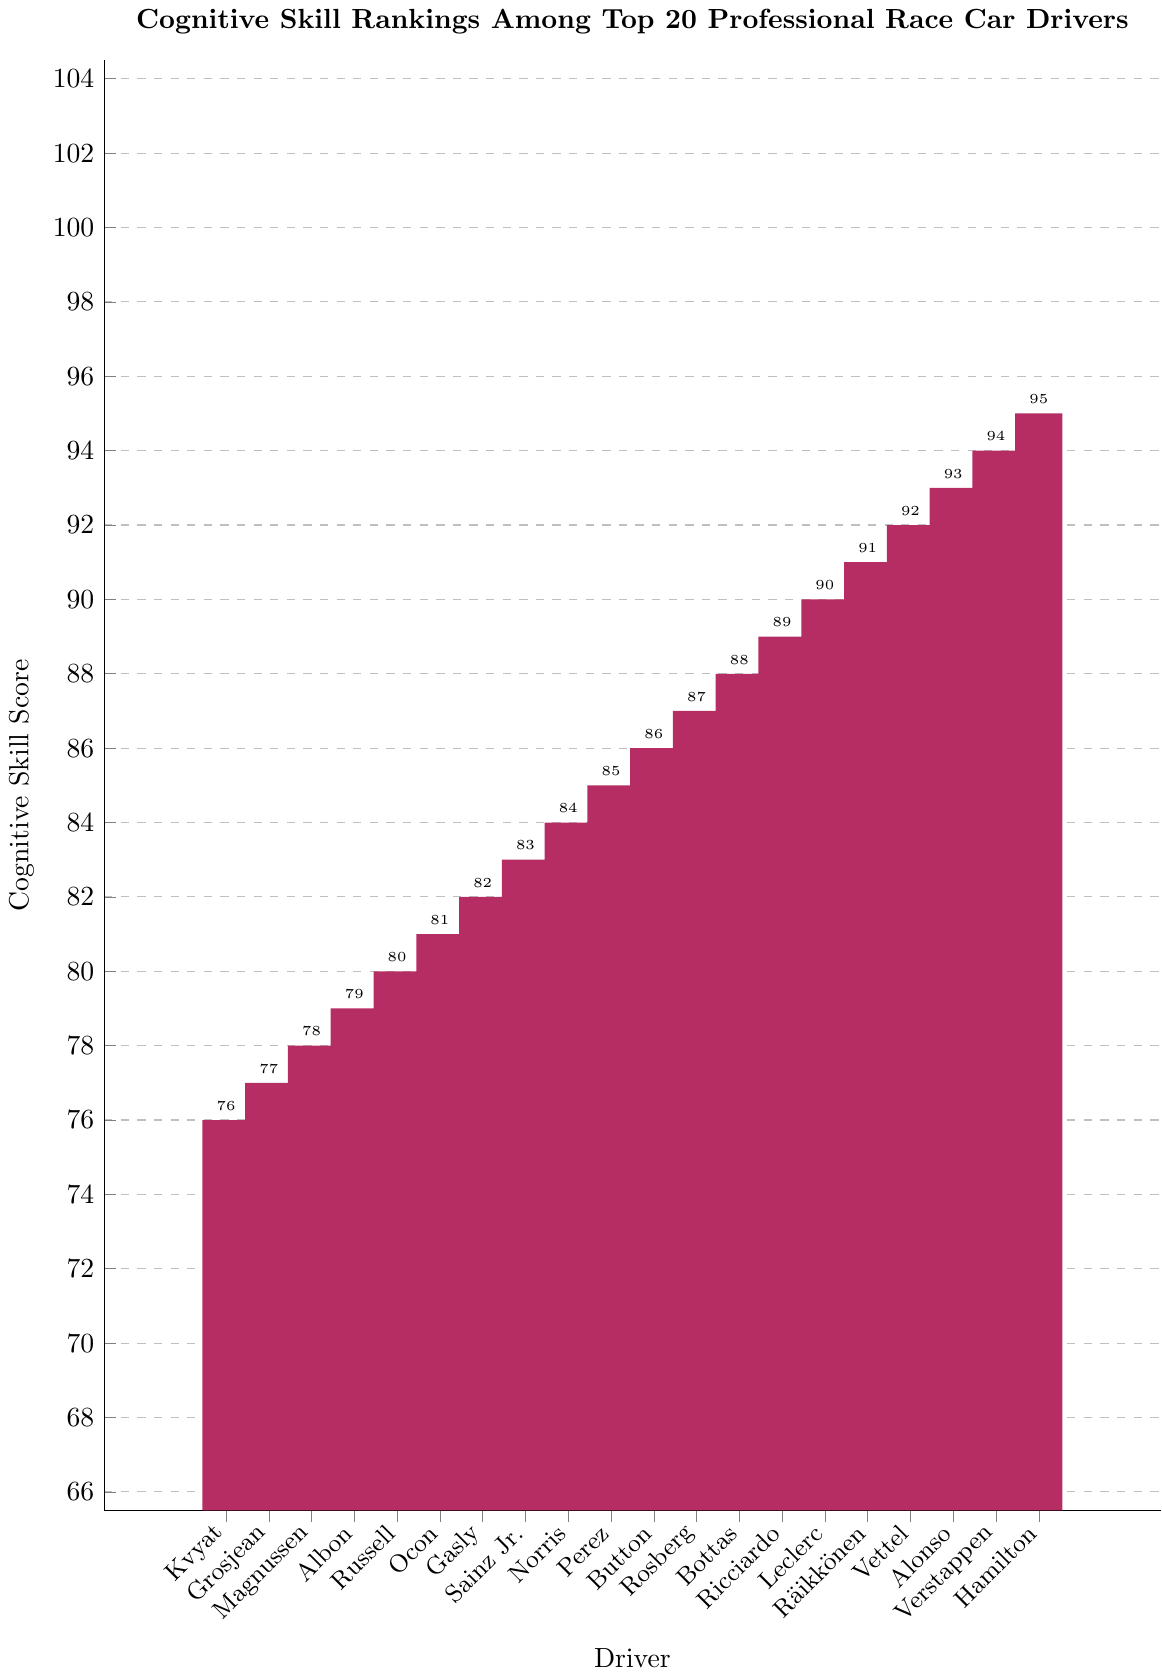What's the highest cognitive skill score among the drivers? By looking at the bar chart, we can identify the tallest bar that represents the driver with the highest cognitive skill score. In this case, the tallest bar is for Lewis Hamilton, with a cognitive skill score of 95.
Answer: 95 Which driver has the lowest cognitive skill score? To find the driver with the lowest cognitive skill score, we look for the shortest bar in the chart. The shortest bar corresponds to Daniil Kvyat, with a score of 76.
Answer: Daniil Kvyat What is the average cognitive skill score of the top 5 drivers? To calculate the average cognitive skill score of the top 5 drivers, we add their scores and divide by 5. The scores are 95, 94, 93, 92, and 91. The sum is 95 + 94 + 93 + 92 + 91 = 465. Dividing by 5, the average is 465/5 = 93.
Answer: 93 How many drivers have a cognitive skill score of 90 or above? By counting the bars that reach 90 or higher, we find that there are 6 drivers (Lewis Hamilton, Max Verstappen, Fernando Alonso, Sebastian Vettel, Kimi Räikkönen, Charles Leclerc).
Answer: 6 Which driver has a cognitive skill score closest to the average score of all drivers? First, calculate the average score of all drivers by summing all scores and dividing by the number of drivers. The sum is 95 + 94 + ... + 76 = 1710. Dividing by 20, the average is 1710/20 = 85.5. The closest score to 85.5 is 85, which belongs to Sergio Perez.
Answer: Sergio Perez What's the difference in cognitive skill score between Lewis Hamilton and Daniil Kvyat? The cognitive skill score for Lewis Hamilton is 95, and for Daniil Kvyat, it is 76. The difference is 95 - 76 = 19.
Answer: 19 Which drivers have scores between 80 and 85 inclusive? By identifying the bars that fall within the range of 80 to 85, the drivers are George Russell (80), Esteban Ocon (81), Pierre Gasly (82), Carlos Sainz Jr. (83), and Lando Norris (84), with Sergio Perez at 85.
Answer: George Russell, Esteban Ocon, Pierre Gasly, Carlos Sainz Jr., Lando Norris, Sergio Perez How many drivers have cognitive skill scores that are greater than 89? Count the bars with scores over 89. The drivers are Lewis Hamilton, Max Verstappen, Fernando Alonso, Sebastian Vettel, Kimi Räikkönen, and Charles Leclerc. Thus, there are 6 drivers.
Answer: 6 Which driver has a cognitive skill score exactly 10 points higher than Daniil Kvyat? Daniil Kvyat has a score of 76. Adding 10 gives us 86. The driver with a score of 86 is Jenson Button.
Answer: Jenson Button 